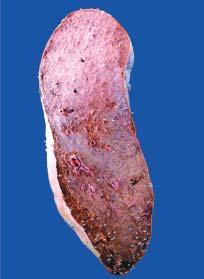s the cut surface grey-tan?
Answer the question using a single word or phrase. No 